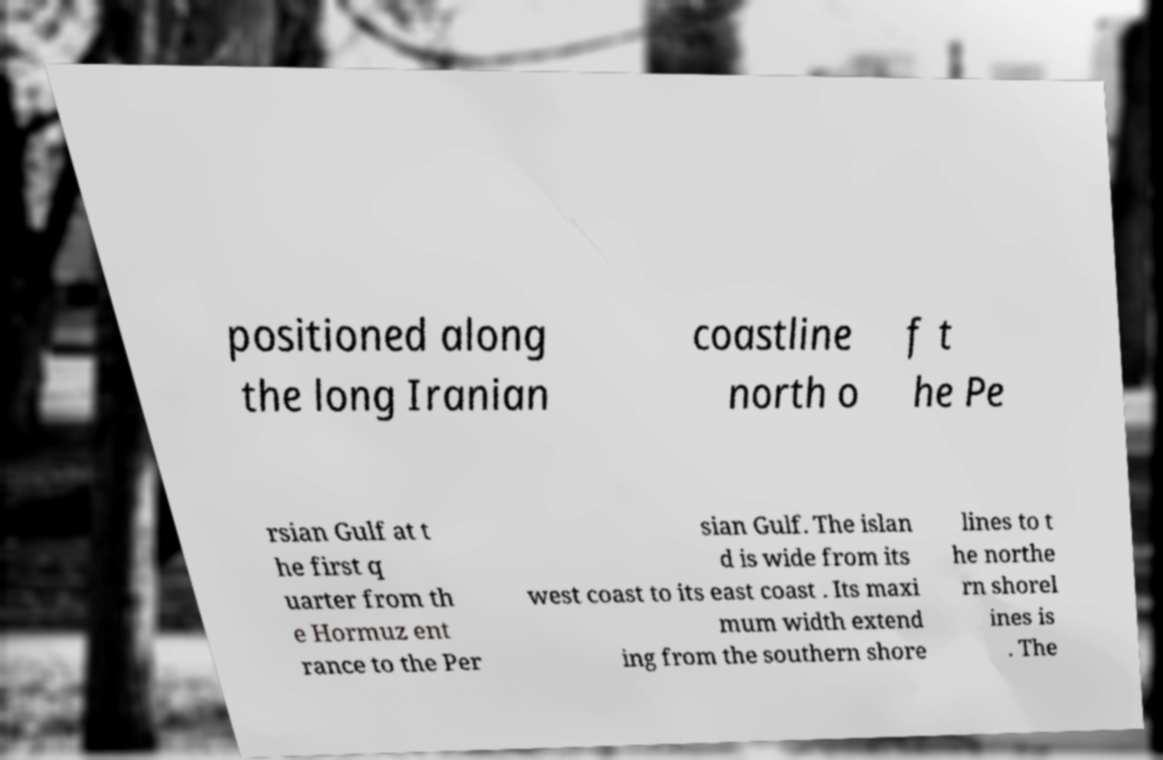Could you extract and type out the text from this image? positioned along the long Iranian coastline north o f t he Pe rsian Gulf at t he first q uarter from th e Hormuz ent rance to the Per sian Gulf. The islan d is wide from its west coast to its east coast . Its maxi mum width extend ing from the southern shore lines to t he northe rn shorel ines is . The 